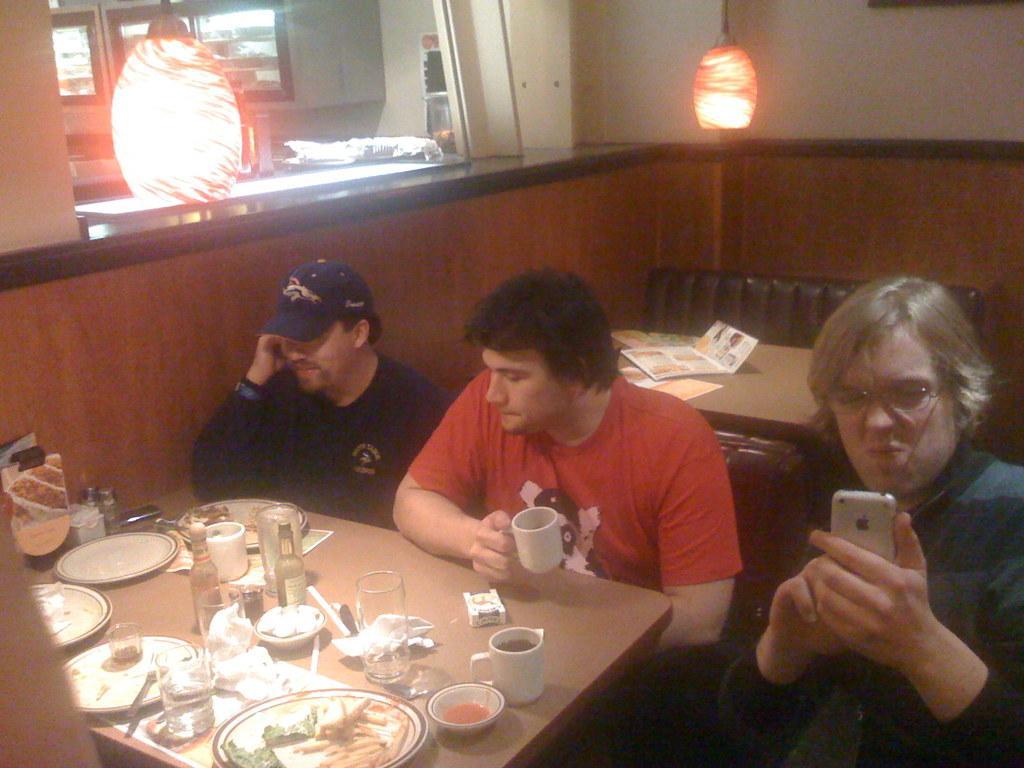Please provide a concise description of this image. This image consists of lights on the top and there are tables and chairs. People are sitting on chairs. On the table there are plates, glasses, bottles, Cups, mobile phones. This looks like a restaurant. 